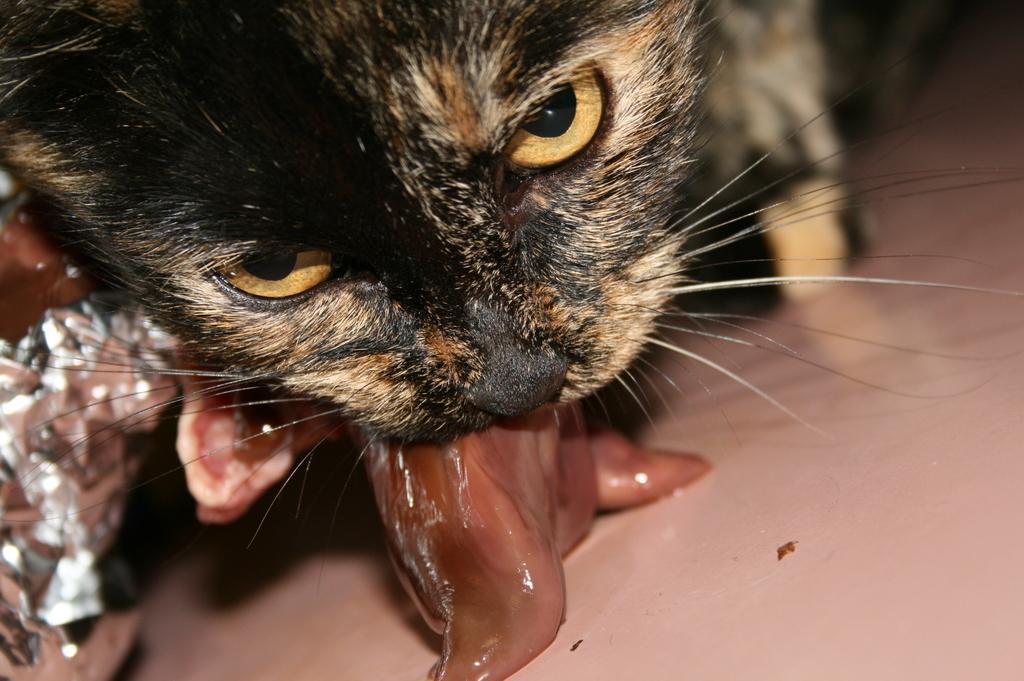Describe this image in one or two sentences. In this picture there is a cat who is holding some meet in his mouth. In the bottom left corner there is a foil paper. 